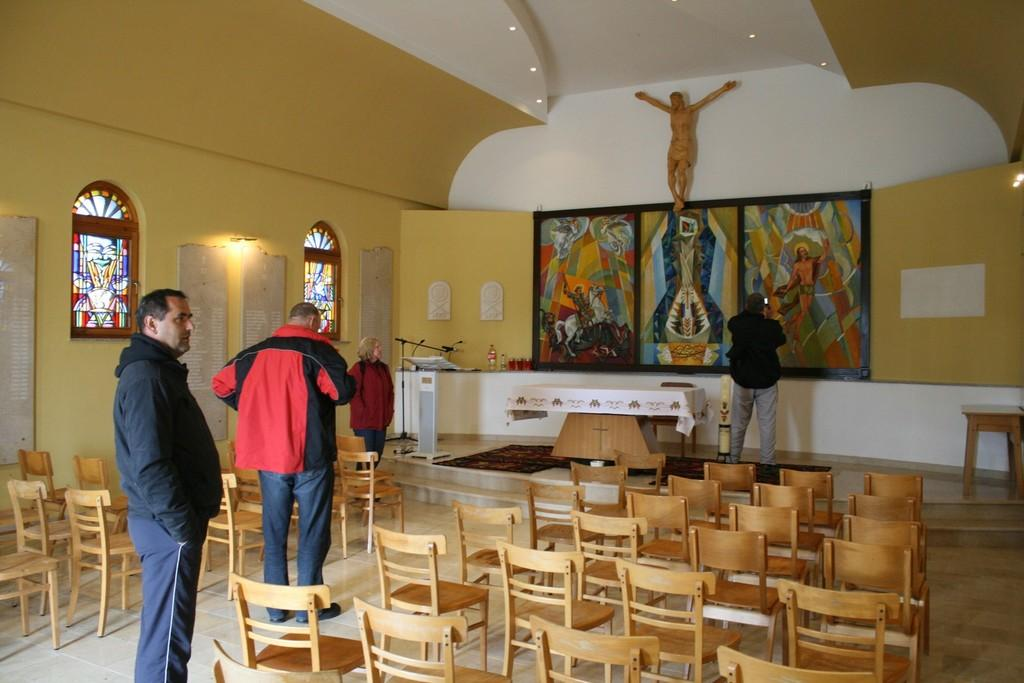How many people are present in the image? There are four people standing in the image. What are the people doing in the image? One person is taking photographs of a photo on the wall. What type of furniture can be seen in the image? There are chairs and a table in the image. How many snails can be seen on the table in the image? There are no snails present in the image. Who is the representative of the group in the image? The image does not indicate a specific representative for the group. 